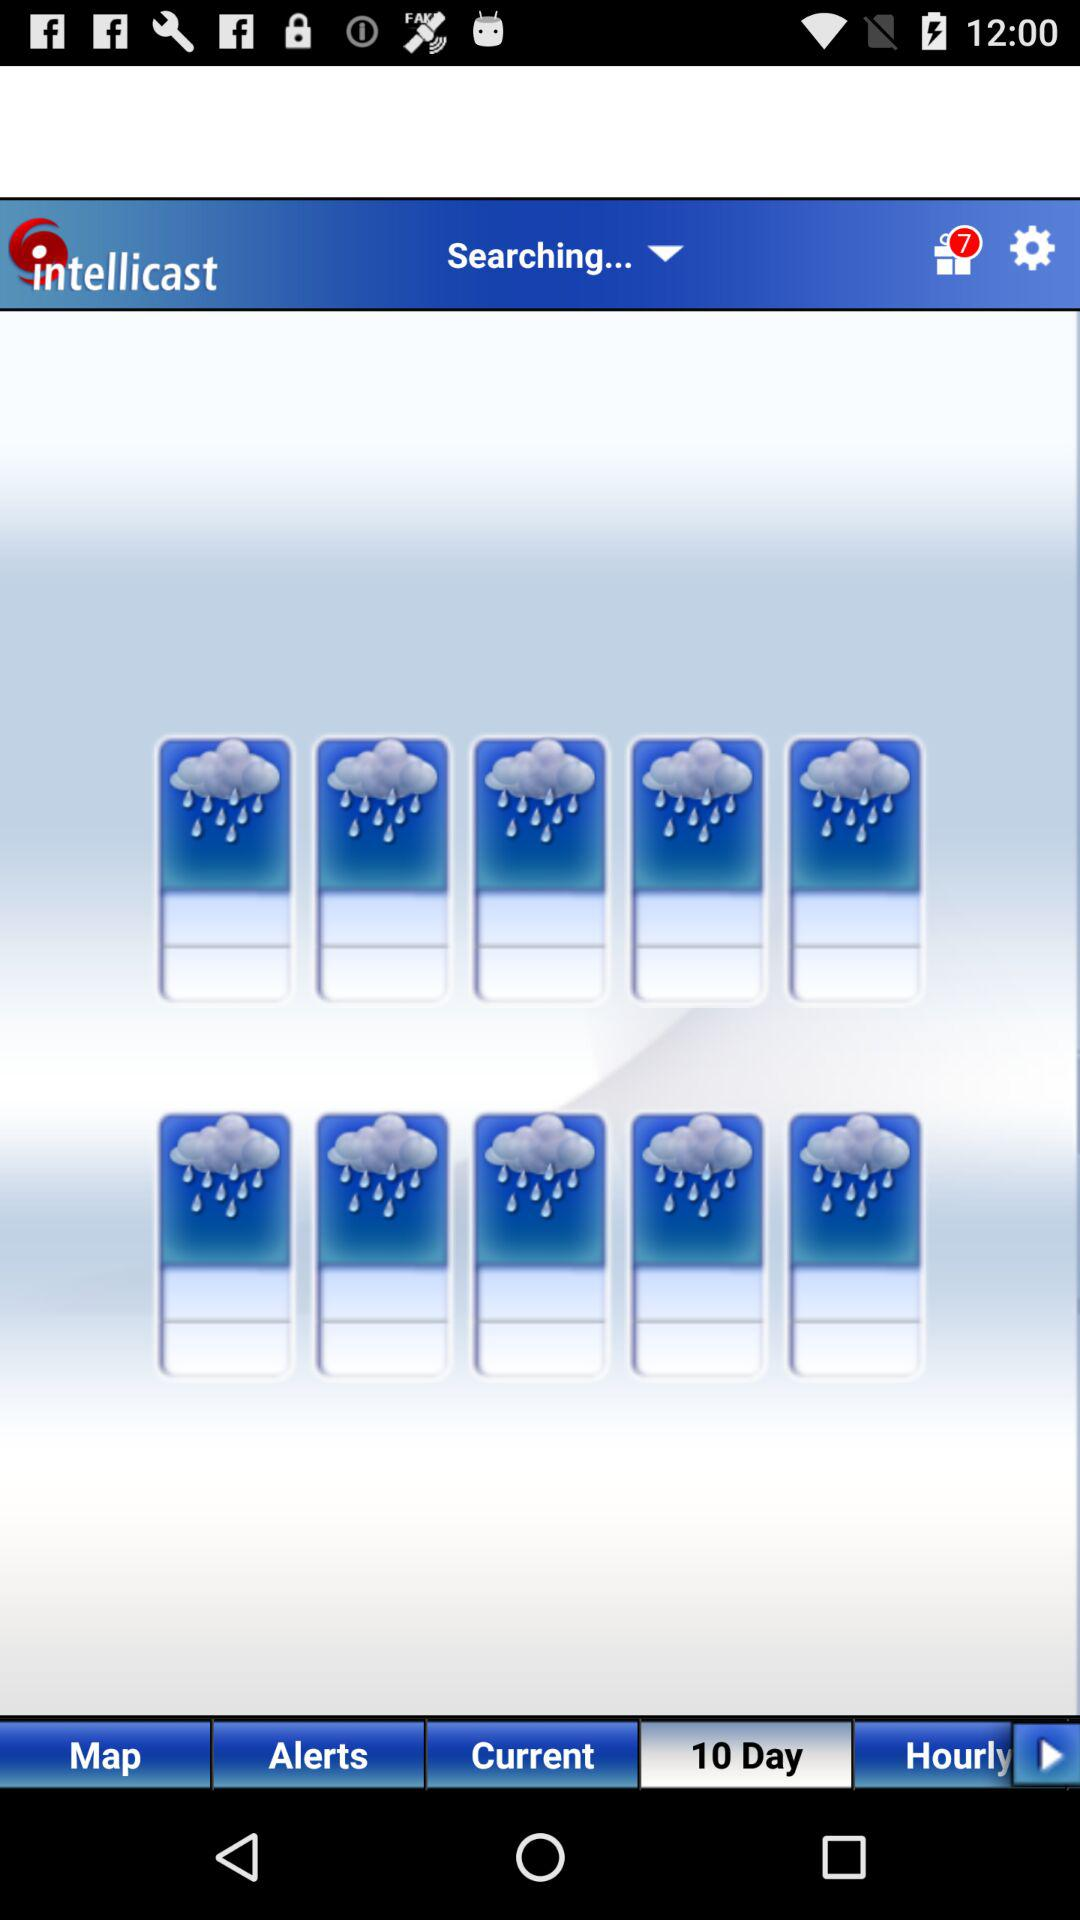How many gifts are there? There are 7 gifts. 